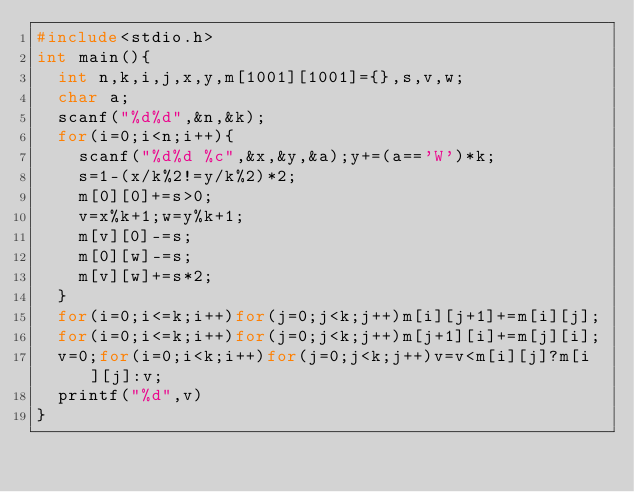<code> <loc_0><loc_0><loc_500><loc_500><_C_>#include<stdio.h>
int main(){
  int n,k,i,j,x,y,m[1001][1001]={},s,v,w;
  char a;
  scanf("%d%d",&n,&k);
  for(i=0;i<n;i++){
    scanf("%d%d %c",&x,&y,&a);y+=(a=='W')*k;
    s=1-(x/k%2!=y/k%2)*2;
    m[0][0]+=s>0;
    v=x%k+1;w=y%k+1;
    m[v][0]-=s;
    m[0][w]-=s;
    m[v][w]+=s*2;
  }
  for(i=0;i<=k;i++)for(j=0;j<k;j++)m[i][j+1]+=m[i][j];
  for(i=0;i<=k;i++)for(j=0;j<k;j++)m[j+1][i]+=m[j][i];
  v=0;for(i=0;i<k;i++)for(j=0;j<k;j++)v=v<m[i][j]?m[i][j]:v;
  printf("%d",v)
}
</code> 